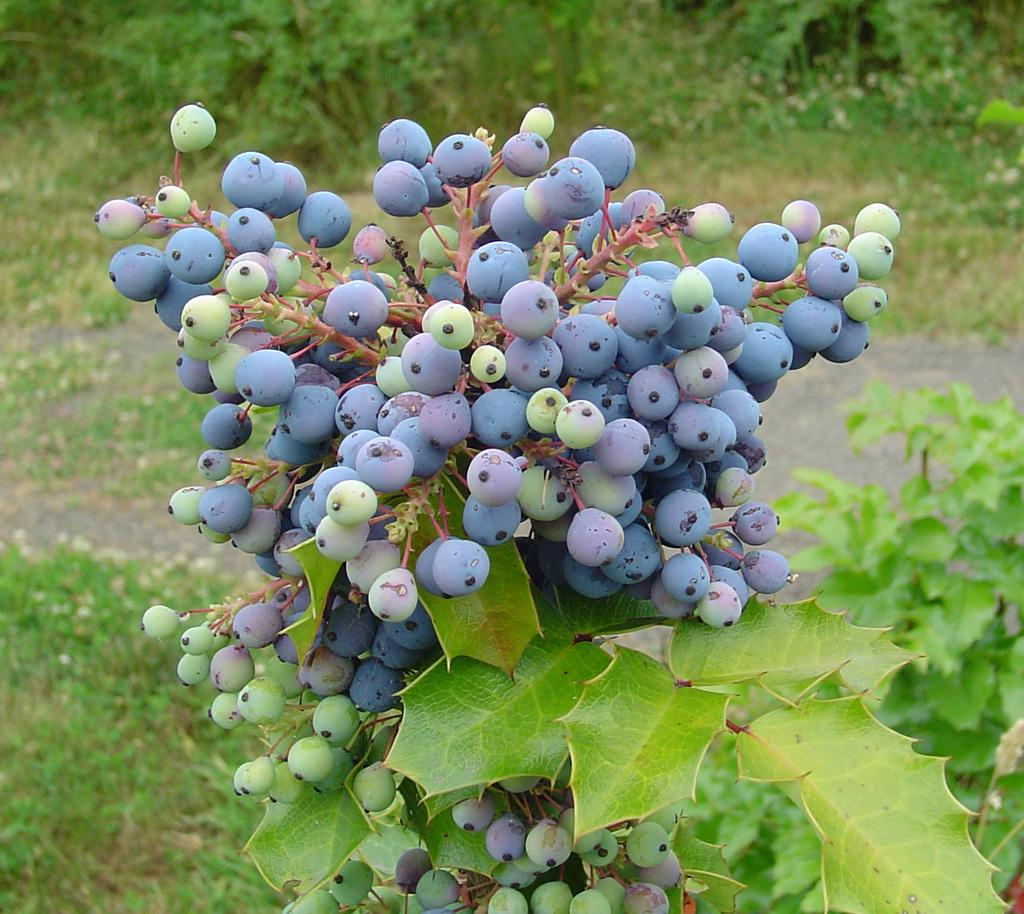What type of plant is featured in the image? There is a plant with bilberry fruits and leaves in the image. What can be seen in the background of the image? There are trees in the background of the image. What type of vegetation is visible in the foreground of the image? There is grass visible in the image. Where is the lake located in the image? There is no lake present in the image. What type of cap is the plant wearing in the image? The plant does not have a cap, as it is a living organism and not a person. 